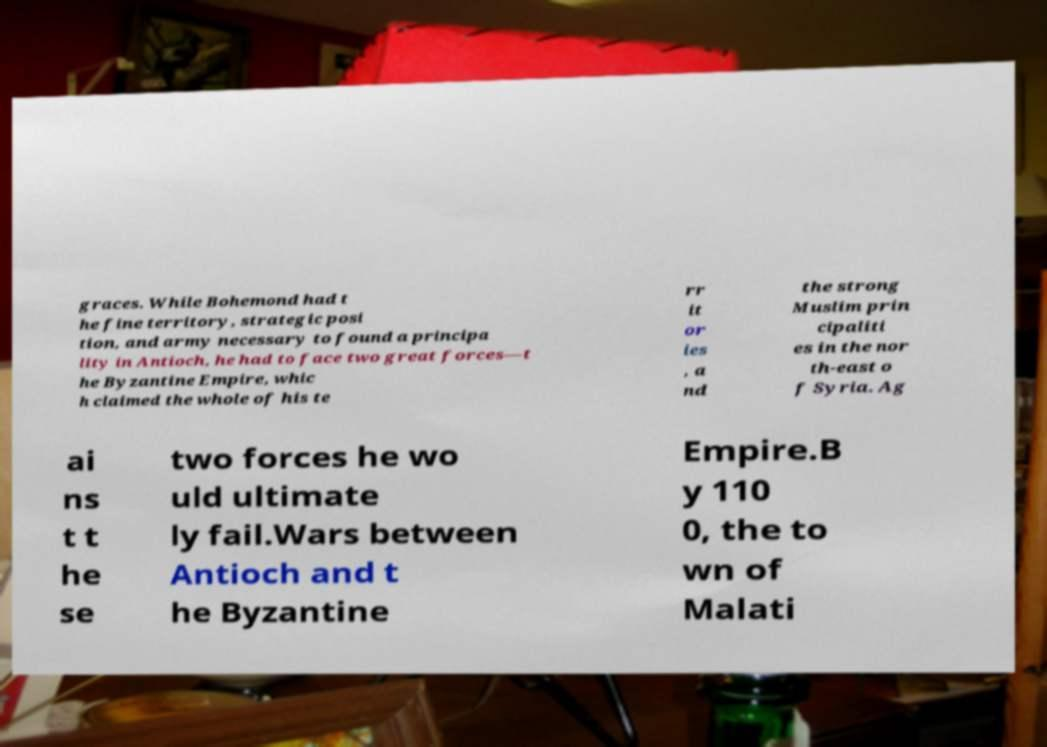There's text embedded in this image that I need extracted. Can you transcribe it verbatim? graces. While Bohemond had t he fine territory, strategic posi tion, and army necessary to found a principa lity in Antioch, he had to face two great forces—t he Byzantine Empire, whic h claimed the whole of his te rr it or ies , a nd the strong Muslim prin cipaliti es in the nor th-east o f Syria. Ag ai ns t t he se two forces he wo uld ultimate ly fail.Wars between Antioch and t he Byzantine Empire.B y 110 0, the to wn of Malati 